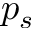<formula> <loc_0><loc_0><loc_500><loc_500>p _ { s }</formula> 